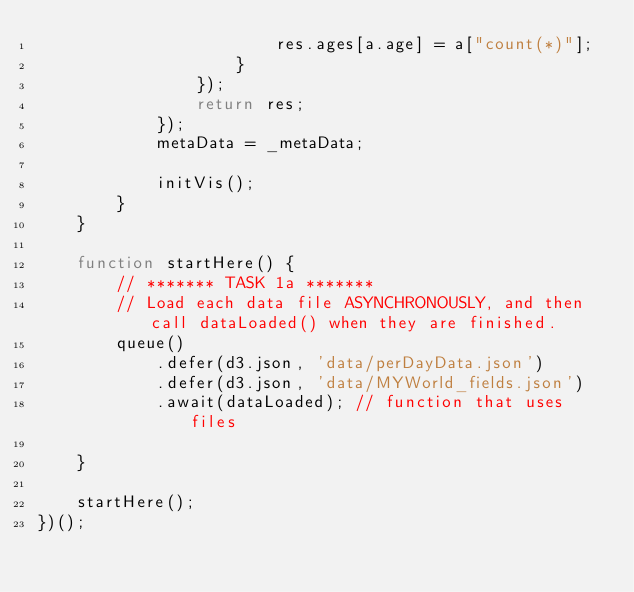Convert code to text. <code><loc_0><loc_0><loc_500><loc_500><_JavaScript_>                        res.ages[a.age] = a["count(*)"];
                    }
                });
                return res;
            });
            metaData = _metaData;

            initVis();
        }
    }

    function startHere() {
        // ******* TASK 1a *******
        // Load each data file ASYNCHRONOUSLY, and then call dataLoaded() when they are finished.
        queue()
			.defer(d3.json, 'data/perDayData.json') 
			.defer(d3.json, 'data/MYWorld_fields.json')
			.await(dataLoaded); // function that uses files
        
    }
    
    startHere();
})();
</code> 